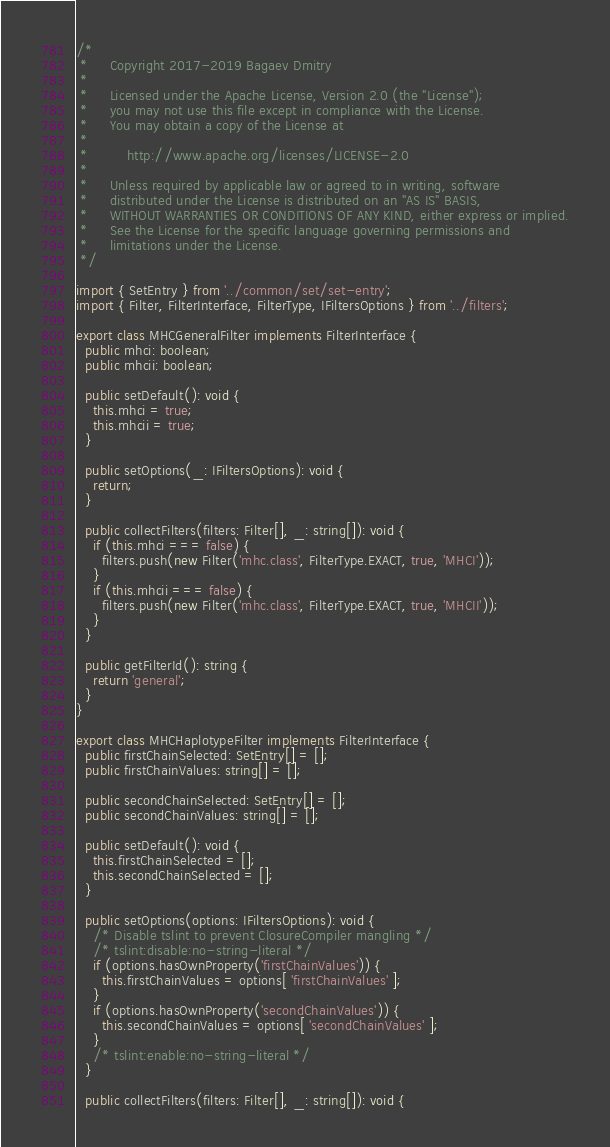Convert code to text. <code><loc_0><loc_0><loc_500><loc_500><_TypeScript_>/*
 *     Copyright 2017-2019 Bagaev Dmitry
 *
 *     Licensed under the Apache License, Version 2.0 (the "License");
 *     you may not use this file except in compliance with the License.
 *     You may obtain a copy of the License at
 *
 *         http://www.apache.org/licenses/LICENSE-2.0
 *
 *     Unless required by applicable law or agreed to in writing, software
 *     distributed under the License is distributed on an "AS IS" BASIS,
 *     WITHOUT WARRANTIES OR CONDITIONS OF ANY KIND, either express or implied.
 *     See the License for the specific language governing permissions and
 *     limitations under the License.
 */

import { SetEntry } from '../common/set/set-entry';
import { Filter, FilterInterface, FilterType, IFiltersOptions } from '../filters';

export class MHCGeneralFilter implements FilterInterface {
  public mhci: boolean;
  public mhcii: boolean;

  public setDefault(): void {
    this.mhci = true;
    this.mhcii = true;
  }

  public setOptions(_: IFiltersOptions): void {
    return;
  }

  public collectFilters(filters: Filter[], _: string[]): void {
    if (this.mhci === false) {
      filters.push(new Filter('mhc.class', FilterType.EXACT, true, 'MHCI'));
    }
    if (this.mhcii === false) {
      filters.push(new Filter('mhc.class', FilterType.EXACT, true, 'MHCII'));
    }
  }

  public getFilterId(): string {
    return 'general';
  }
}

export class MHCHaplotypeFilter implements FilterInterface {
  public firstChainSelected: SetEntry[] = [];
  public firstChainValues: string[] = [];

  public secondChainSelected: SetEntry[] = [];
  public secondChainValues: string[] = [];

  public setDefault(): void {
    this.firstChainSelected = [];
    this.secondChainSelected = [];
  }

  public setOptions(options: IFiltersOptions): void {
    /* Disable tslint to prevent ClosureCompiler mangling */
    /* tslint:disable:no-string-literal */
    if (options.hasOwnProperty('firstChainValues')) {
      this.firstChainValues = options[ 'firstChainValues' ];
    }
    if (options.hasOwnProperty('secondChainValues')) {
      this.secondChainValues = options[ 'secondChainValues' ];
    }
    /* tslint:enable:no-string-literal */
  }

  public collectFilters(filters: Filter[], _: string[]): void {</code> 